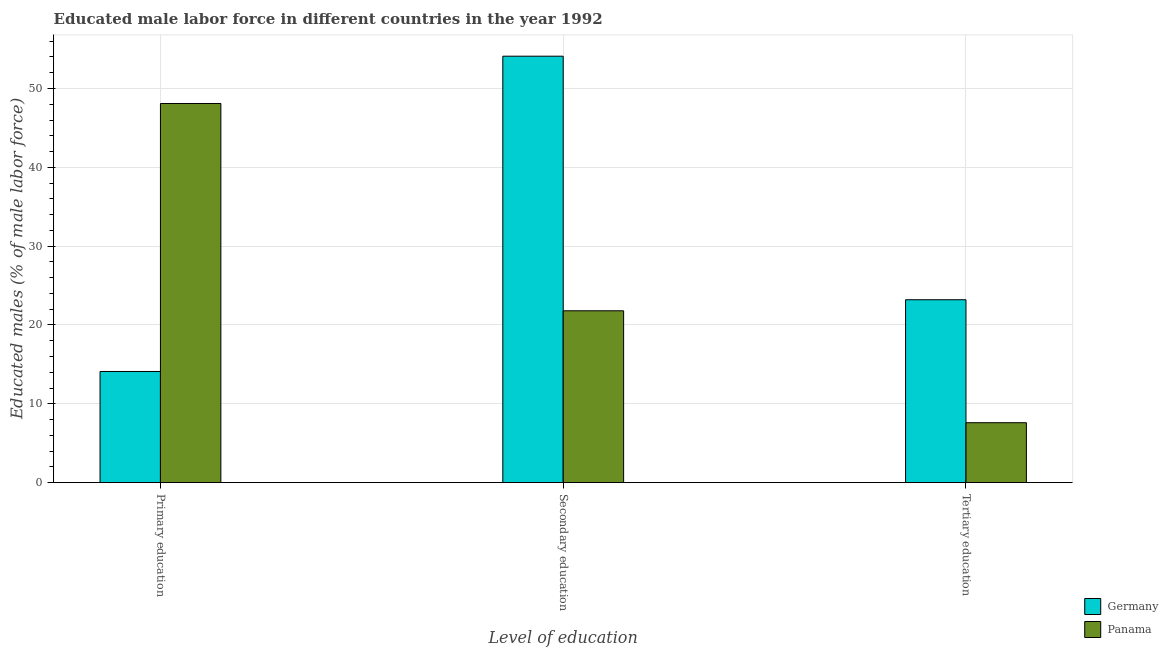How many different coloured bars are there?
Offer a very short reply. 2. What is the label of the 1st group of bars from the left?
Make the answer very short. Primary education. What is the percentage of male labor force who received secondary education in Panama?
Your answer should be compact. 21.8. Across all countries, what is the maximum percentage of male labor force who received primary education?
Give a very brief answer. 48.1. Across all countries, what is the minimum percentage of male labor force who received tertiary education?
Offer a terse response. 7.6. In which country was the percentage of male labor force who received secondary education minimum?
Provide a short and direct response. Panama. What is the total percentage of male labor force who received secondary education in the graph?
Offer a terse response. 75.9. What is the difference between the percentage of male labor force who received primary education in Germany and that in Panama?
Your response must be concise. -34. What is the difference between the percentage of male labor force who received tertiary education in Panama and the percentage of male labor force who received secondary education in Germany?
Provide a short and direct response. -46.5. What is the average percentage of male labor force who received secondary education per country?
Offer a very short reply. 37.95. What is the difference between the percentage of male labor force who received secondary education and percentage of male labor force who received tertiary education in Panama?
Your response must be concise. 14.2. What is the ratio of the percentage of male labor force who received secondary education in Panama to that in Germany?
Offer a very short reply. 0.4. Is the difference between the percentage of male labor force who received tertiary education in Panama and Germany greater than the difference between the percentage of male labor force who received primary education in Panama and Germany?
Make the answer very short. No. What is the difference between the highest and the second highest percentage of male labor force who received secondary education?
Your answer should be compact. 32.3. What is the difference between the highest and the lowest percentage of male labor force who received primary education?
Make the answer very short. 34. Is the sum of the percentage of male labor force who received secondary education in Panama and Germany greater than the maximum percentage of male labor force who received tertiary education across all countries?
Your answer should be very brief. Yes. What does the 2nd bar from the left in Secondary education represents?
Your response must be concise. Panama. What does the 2nd bar from the right in Secondary education represents?
Give a very brief answer. Germany. How many bars are there?
Provide a short and direct response. 6. Are all the bars in the graph horizontal?
Your answer should be very brief. No. What is the difference between two consecutive major ticks on the Y-axis?
Make the answer very short. 10. Does the graph contain any zero values?
Provide a succinct answer. No. How many legend labels are there?
Provide a short and direct response. 2. How are the legend labels stacked?
Offer a very short reply. Vertical. What is the title of the graph?
Provide a short and direct response. Educated male labor force in different countries in the year 1992. Does "Albania" appear as one of the legend labels in the graph?
Make the answer very short. No. What is the label or title of the X-axis?
Provide a short and direct response. Level of education. What is the label or title of the Y-axis?
Your answer should be very brief. Educated males (% of male labor force). What is the Educated males (% of male labor force) of Germany in Primary education?
Ensure brevity in your answer.  14.1. What is the Educated males (% of male labor force) of Panama in Primary education?
Ensure brevity in your answer.  48.1. What is the Educated males (% of male labor force) of Germany in Secondary education?
Keep it short and to the point. 54.1. What is the Educated males (% of male labor force) in Panama in Secondary education?
Your answer should be compact. 21.8. What is the Educated males (% of male labor force) of Germany in Tertiary education?
Provide a succinct answer. 23.2. What is the Educated males (% of male labor force) in Panama in Tertiary education?
Ensure brevity in your answer.  7.6. Across all Level of education, what is the maximum Educated males (% of male labor force) of Germany?
Keep it short and to the point. 54.1. Across all Level of education, what is the maximum Educated males (% of male labor force) of Panama?
Give a very brief answer. 48.1. Across all Level of education, what is the minimum Educated males (% of male labor force) in Germany?
Your answer should be compact. 14.1. Across all Level of education, what is the minimum Educated males (% of male labor force) of Panama?
Keep it short and to the point. 7.6. What is the total Educated males (% of male labor force) of Germany in the graph?
Provide a succinct answer. 91.4. What is the total Educated males (% of male labor force) of Panama in the graph?
Make the answer very short. 77.5. What is the difference between the Educated males (% of male labor force) of Germany in Primary education and that in Secondary education?
Your response must be concise. -40. What is the difference between the Educated males (% of male labor force) of Panama in Primary education and that in Secondary education?
Offer a terse response. 26.3. What is the difference between the Educated males (% of male labor force) of Germany in Primary education and that in Tertiary education?
Provide a succinct answer. -9.1. What is the difference between the Educated males (% of male labor force) in Panama in Primary education and that in Tertiary education?
Keep it short and to the point. 40.5. What is the difference between the Educated males (% of male labor force) in Germany in Secondary education and that in Tertiary education?
Ensure brevity in your answer.  30.9. What is the difference between the Educated males (% of male labor force) in Panama in Secondary education and that in Tertiary education?
Keep it short and to the point. 14.2. What is the difference between the Educated males (% of male labor force) of Germany in Primary education and the Educated males (% of male labor force) of Panama in Tertiary education?
Provide a succinct answer. 6.5. What is the difference between the Educated males (% of male labor force) of Germany in Secondary education and the Educated males (% of male labor force) of Panama in Tertiary education?
Ensure brevity in your answer.  46.5. What is the average Educated males (% of male labor force) of Germany per Level of education?
Make the answer very short. 30.47. What is the average Educated males (% of male labor force) of Panama per Level of education?
Give a very brief answer. 25.83. What is the difference between the Educated males (% of male labor force) in Germany and Educated males (% of male labor force) in Panama in Primary education?
Your answer should be very brief. -34. What is the difference between the Educated males (% of male labor force) in Germany and Educated males (% of male labor force) in Panama in Secondary education?
Your answer should be compact. 32.3. What is the difference between the Educated males (% of male labor force) in Germany and Educated males (% of male labor force) in Panama in Tertiary education?
Make the answer very short. 15.6. What is the ratio of the Educated males (% of male labor force) in Germany in Primary education to that in Secondary education?
Your answer should be very brief. 0.26. What is the ratio of the Educated males (% of male labor force) in Panama in Primary education to that in Secondary education?
Provide a succinct answer. 2.21. What is the ratio of the Educated males (% of male labor force) in Germany in Primary education to that in Tertiary education?
Your answer should be very brief. 0.61. What is the ratio of the Educated males (% of male labor force) of Panama in Primary education to that in Tertiary education?
Your answer should be very brief. 6.33. What is the ratio of the Educated males (% of male labor force) in Germany in Secondary education to that in Tertiary education?
Make the answer very short. 2.33. What is the ratio of the Educated males (% of male labor force) of Panama in Secondary education to that in Tertiary education?
Offer a terse response. 2.87. What is the difference between the highest and the second highest Educated males (% of male labor force) in Germany?
Ensure brevity in your answer.  30.9. What is the difference between the highest and the second highest Educated males (% of male labor force) in Panama?
Ensure brevity in your answer.  26.3. What is the difference between the highest and the lowest Educated males (% of male labor force) of Germany?
Ensure brevity in your answer.  40. What is the difference between the highest and the lowest Educated males (% of male labor force) of Panama?
Your answer should be compact. 40.5. 